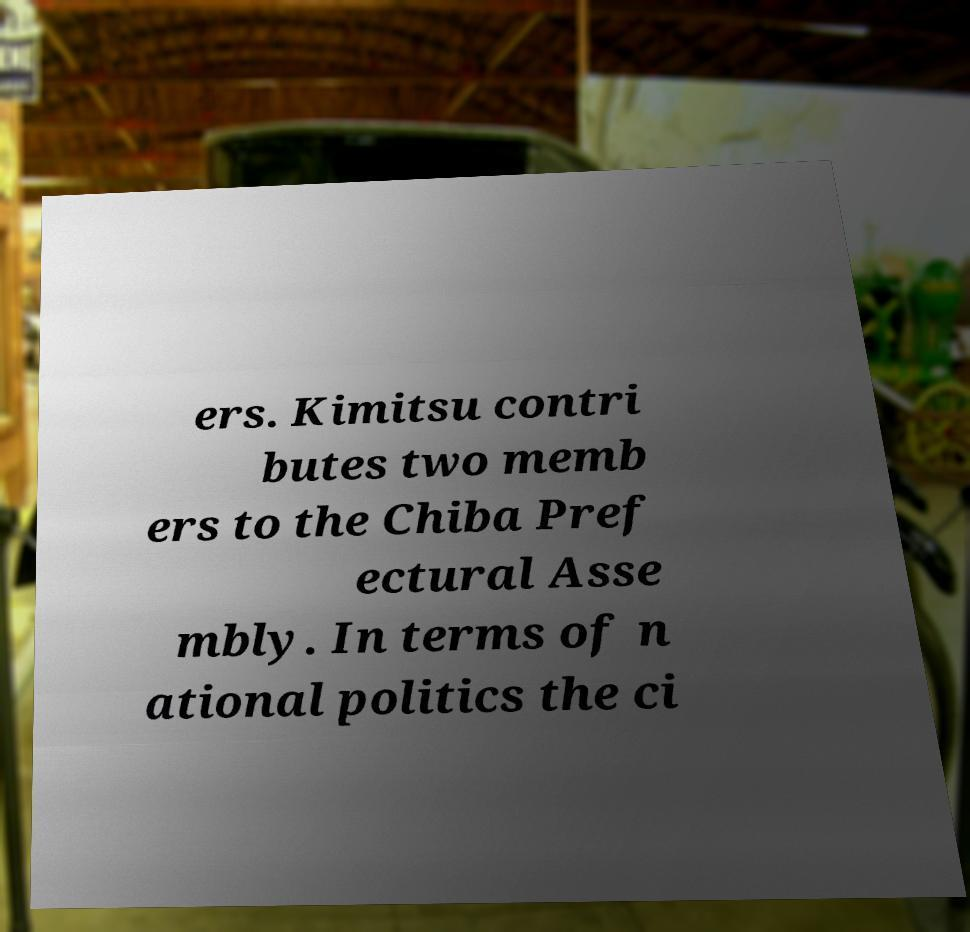Could you assist in decoding the text presented in this image and type it out clearly? ers. Kimitsu contri butes two memb ers to the Chiba Pref ectural Asse mbly. In terms of n ational politics the ci 